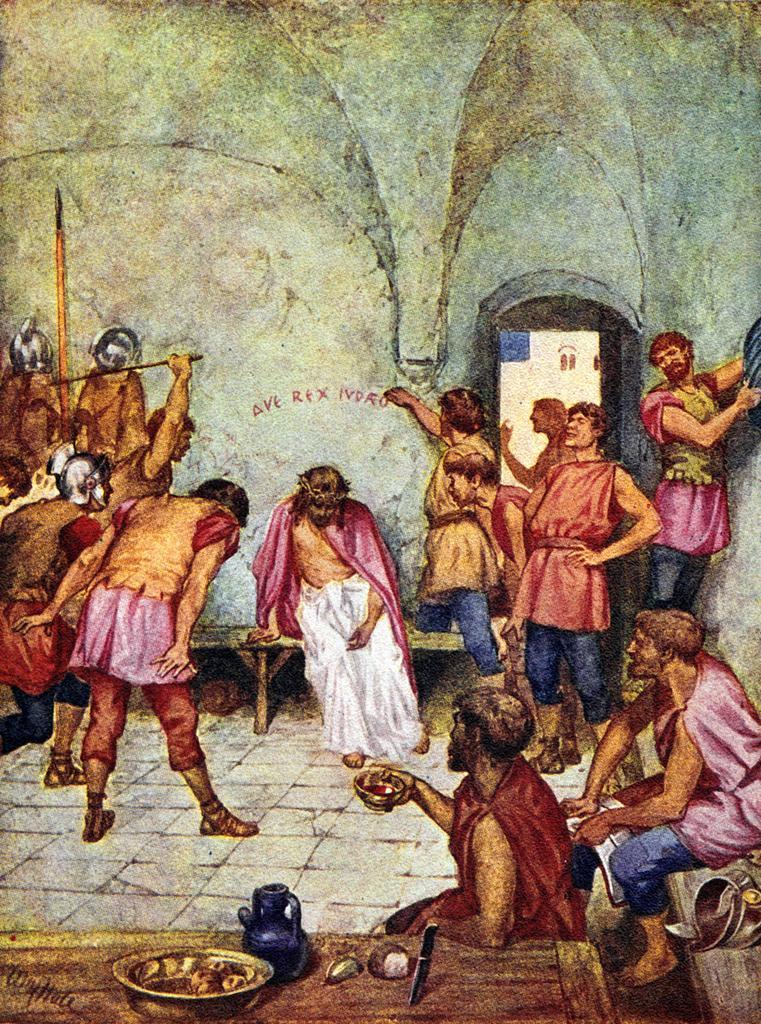How would you summarize this image in a sentence or two? In this picture there are group of people were few among them are standing and holding an object in their hands and the remaining are sitting and there is a person standing and writing something on the wall in the background. 